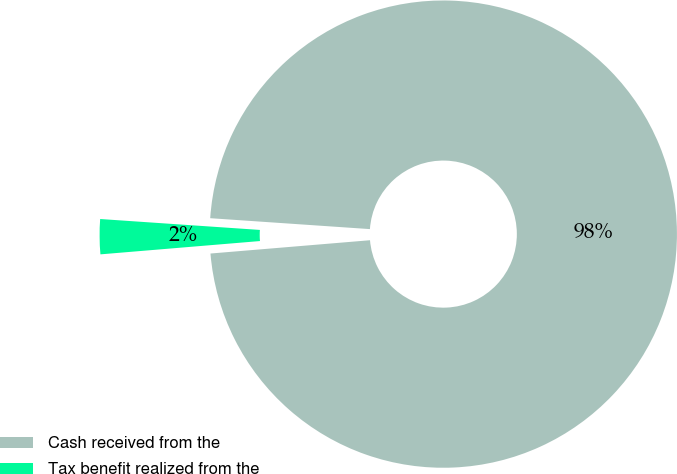<chart> <loc_0><loc_0><loc_500><loc_500><pie_chart><fcel>Cash received from the<fcel>Tax benefit realized from the<nl><fcel>97.59%<fcel>2.41%<nl></chart> 